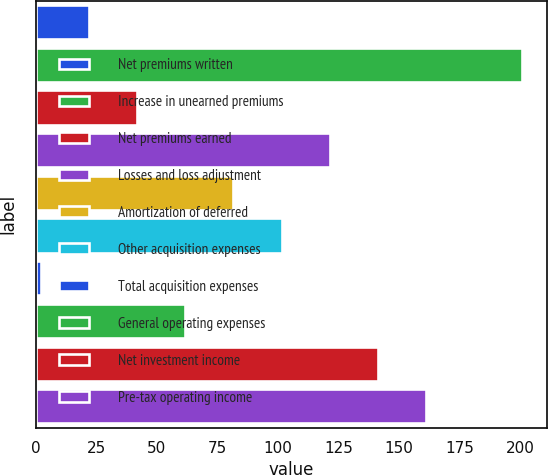Convert chart. <chart><loc_0><loc_0><loc_500><loc_500><bar_chart><fcel>Net premiums written<fcel>Increase in unearned premiums<fcel>Net premiums earned<fcel>Losses and loss adjustment<fcel>Amortization of deferred<fcel>Other acquisition expenses<fcel>Total acquisition expenses<fcel>General operating expenses<fcel>Net investment income<fcel>Pre-tax operating income<nl><fcel>21.9<fcel>201<fcel>41.8<fcel>121.4<fcel>81.6<fcel>101.5<fcel>2<fcel>61.7<fcel>141.3<fcel>161.2<nl></chart> 